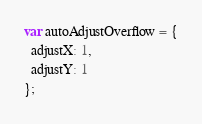Convert code to text. <code><loc_0><loc_0><loc_500><loc_500><_JavaScript_>var autoAdjustOverflow = {
  adjustX: 1,
  adjustY: 1
};
</code> 